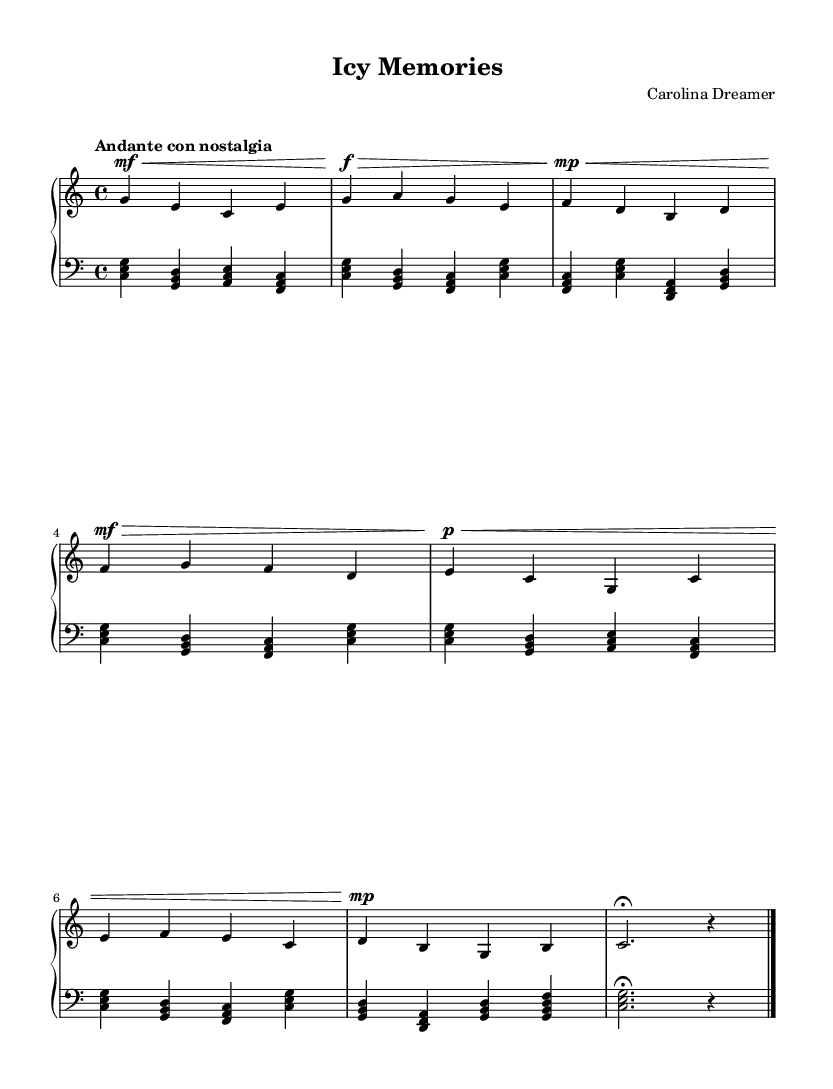What is the key signature of this music? The key signature is C major, which has no sharps or flats.
Answer: C major What is the time signature of the piece? The time signature is indicated as 4/4, meaning there are four beats in each measure.
Answer: 4/4 What is the tempo marking of this piece? The tempo marking provided is "Andante con nostalgia," which indicates a moderately slow tempo with a sense of nostalgia.
Answer: Andante con nostalgia How many measures are in the lower staff? By counting the measures in the lower staff section, you can see there are a total of 8 measures present.
Answer: 8 What is the dynamic marking at the start of the upper staff? The dynamic marking at the beginning is mf (mezzo forte), indicating a moderately loud sound.
Answer: mf Identify one musical characteristic that showcases the Romantic style within this piece. The piece includes expressive dynamics and a flowing melody, which are characteristics typical of Romantic music that evoke deep emotions and nostalgia.
Answer: Expressive dynamics Which notes form the first chord in the lower staff? The first chord in the lower staff is formed by the notes C, E, and G.
Answer: C, E, G 